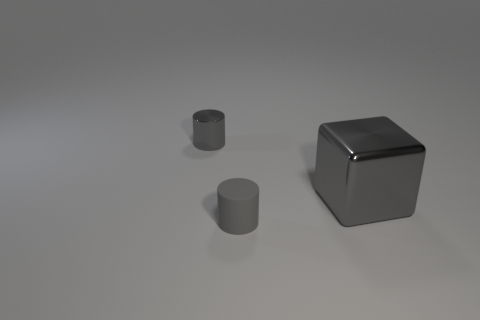Is there any color variation between the objects in the picture? The objects in the image show no color variation; they all exhibit a uniform gray hue, but differences in light reflection and shadow might suggest varying textures or surface treatments. 